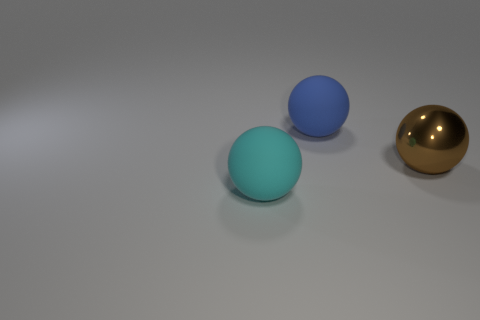There is a big thing that is on the right side of the large cyan object and to the left of the big brown object; what is its color?
Your answer should be very brief. Blue. Are there any big spheres of the same color as the big shiny object?
Offer a very short reply. No. There is a large rubber sphere that is behind the large cyan object; what is its color?
Provide a succinct answer. Blue. There is a big sphere that is in front of the big metallic object; is there a big blue sphere that is left of it?
Your answer should be very brief. No. There is a metal thing; does it have the same color as the big matte ball in front of the big metallic object?
Your answer should be very brief. No. Is there a red cylinder made of the same material as the cyan sphere?
Provide a short and direct response. No. What number of large blue rubber balls are there?
Your answer should be very brief. 1. What material is the thing to the right of the rubber ball on the right side of the big cyan matte ball?
Your answer should be very brief. Metal. The other object that is the same material as the cyan thing is what color?
Your answer should be very brief. Blue. Does the ball that is on the left side of the large blue ball have the same size as the object that is behind the big brown thing?
Make the answer very short. Yes. 